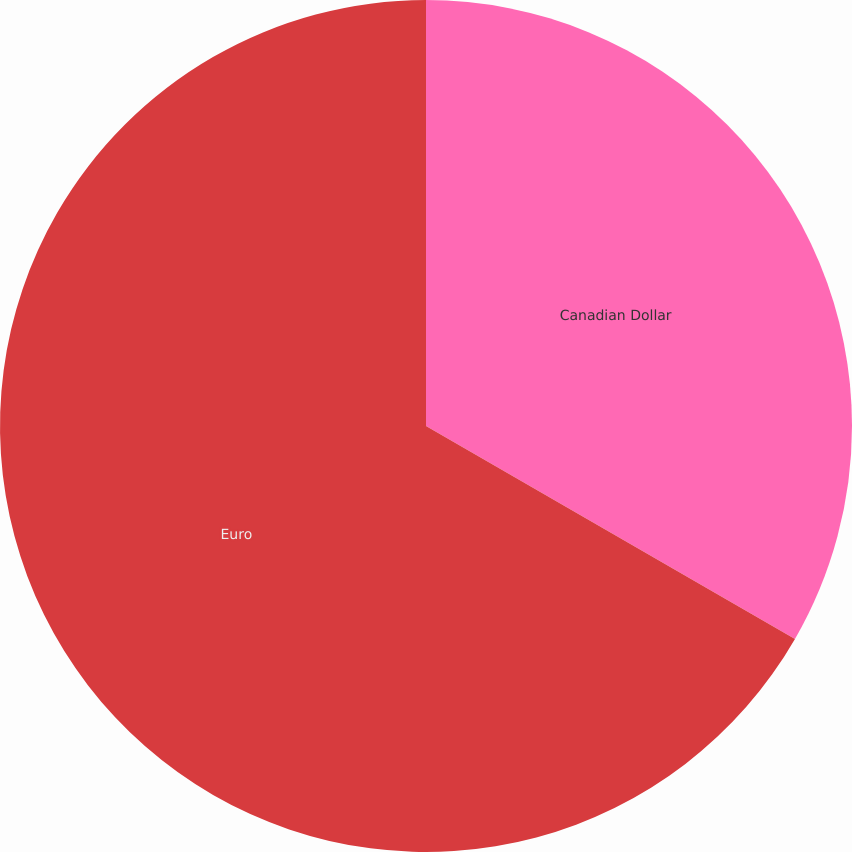Convert chart to OTSL. <chart><loc_0><loc_0><loc_500><loc_500><pie_chart><fcel>Canadian Dollar<fcel>Euro<nl><fcel>33.33%<fcel>66.67%<nl></chart> 